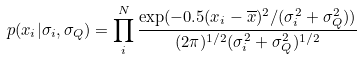Convert formula to latex. <formula><loc_0><loc_0><loc_500><loc_500>p ( x _ { i } | \sigma _ { i } , \sigma _ { Q } ) = \prod _ { i } ^ { N } \frac { \exp ( - 0 . 5 ( x _ { i } - \overline { x } ) ^ { 2 } / ( \sigma _ { i } ^ { 2 } + \sigma _ { Q } ^ { 2 } ) ) } { ( 2 \pi ) ^ { 1 / 2 } ( \sigma _ { i } ^ { 2 } + \sigma _ { Q } ^ { 2 } ) ^ { 1 / 2 } }</formula> 